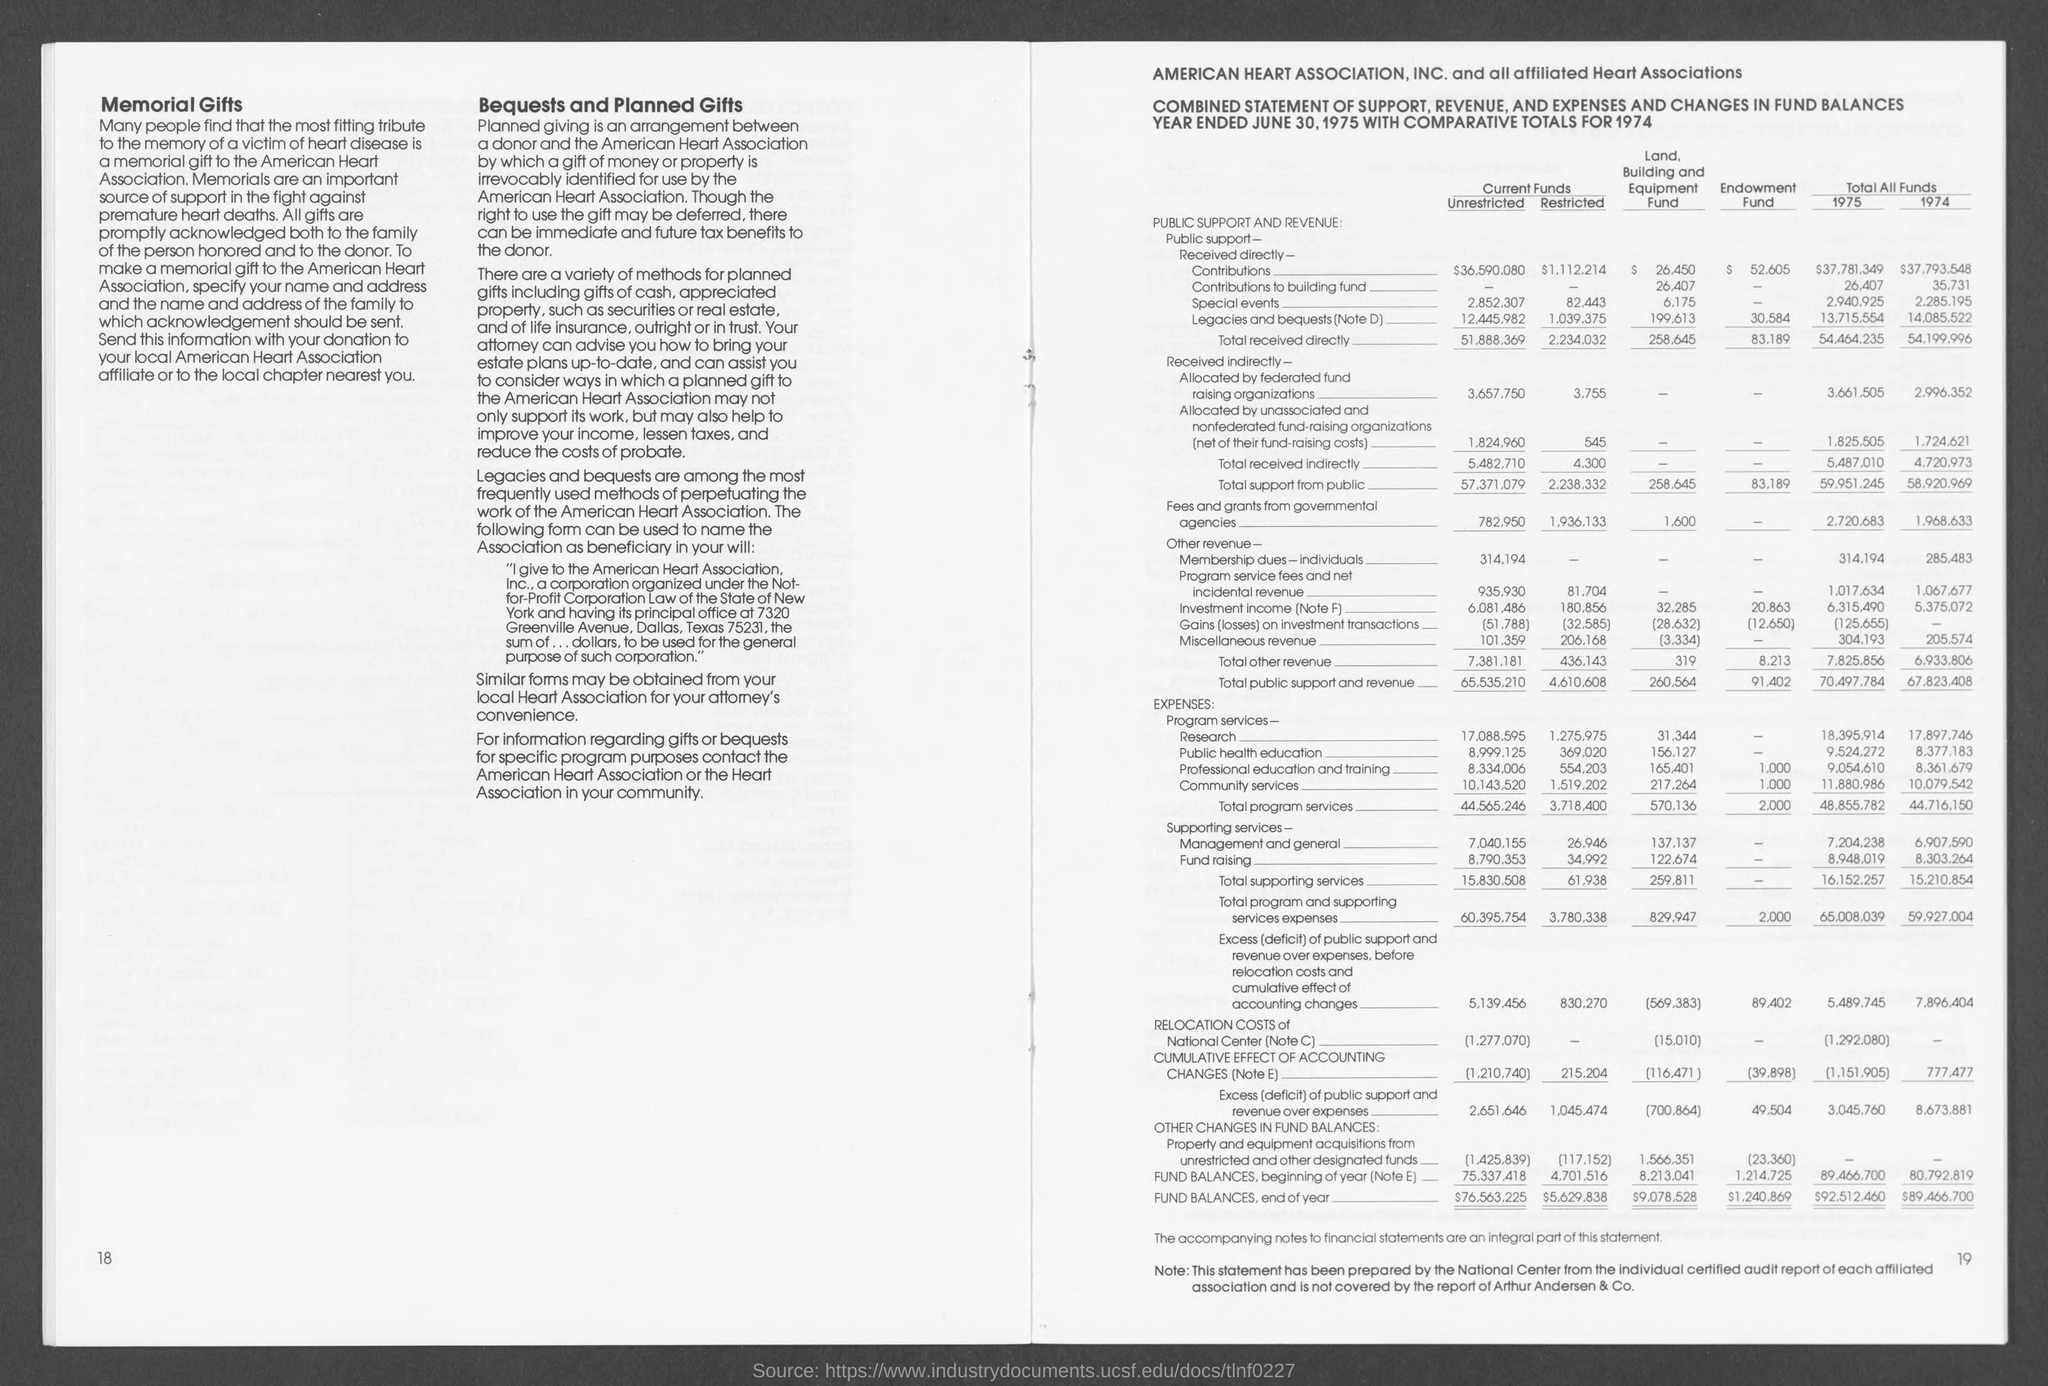What is the total received directly Unrestricted current funds?
Your answer should be very brief. 51,888,369. What is the total received directly restricted current funds?
Your answer should be compact. 2,234,032. 